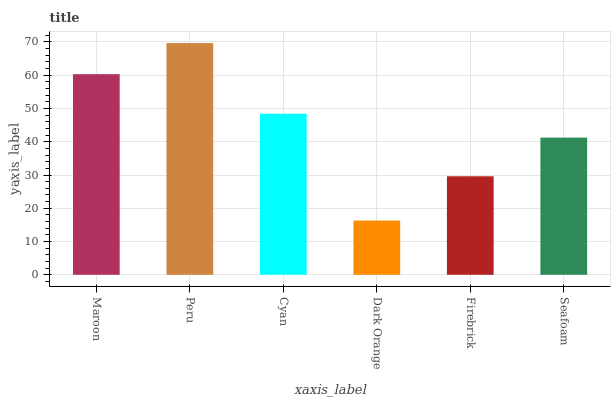Is Dark Orange the minimum?
Answer yes or no. Yes. Is Peru the maximum?
Answer yes or no. Yes. Is Cyan the minimum?
Answer yes or no. No. Is Cyan the maximum?
Answer yes or no. No. Is Peru greater than Cyan?
Answer yes or no. Yes. Is Cyan less than Peru?
Answer yes or no. Yes. Is Cyan greater than Peru?
Answer yes or no. No. Is Peru less than Cyan?
Answer yes or no. No. Is Cyan the high median?
Answer yes or no. Yes. Is Seafoam the low median?
Answer yes or no. Yes. Is Seafoam the high median?
Answer yes or no. No. Is Dark Orange the low median?
Answer yes or no. No. 